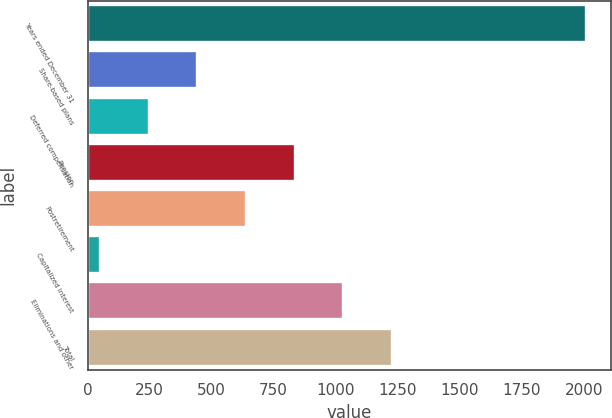Convert chart. <chart><loc_0><loc_0><loc_500><loc_500><bar_chart><fcel>Years ended December 31<fcel>Share-based plans<fcel>Deferred compensation<fcel>Pension<fcel>Postretirement<fcel>Capitalized interest<fcel>Eliminations and other<fcel>Total<nl><fcel>2011<fcel>443<fcel>247<fcel>835<fcel>639<fcel>51<fcel>1031<fcel>1227<nl></chart> 